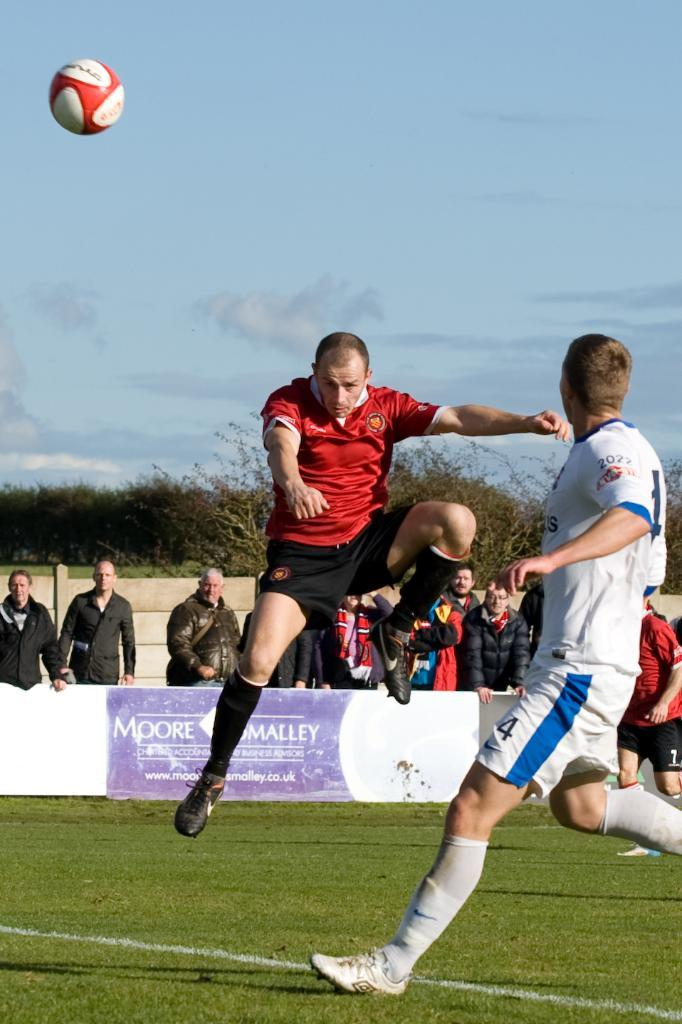<image>
Describe the image concisely. A soccer player jumps up in front of a competing player who wears shorts with the number 4 on them. 